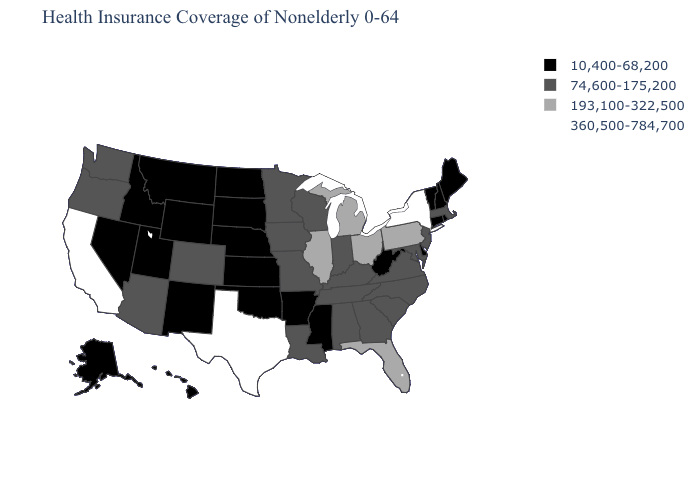Name the states that have a value in the range 193,100-322,500?
Answer briefly. Florida, Illinois, Michigan, Ohio, Pennsylvania. Name the states that have a value in the range 360,500-784,700?
Quick response, please. California, New York, Texas. What is the lowest value in the USA?
Short answer required. 10,400-68,200. Does Ohio have the same value as New Hampshire?
Answer briefly. No. How many symbols are there in the legend?
Answer briefly. 4. What is the lowest value in the USA?
Short answer required. 10,400-68,200. What is the highest value in the MidWest ?
Give a very brief answer. 193,100-322,500. Does Wyoming have the lowest value in the USA?
Be succinct. Yes. Name the states that have a value in the range 193,100-322,500?
Be succinct. Florida, Illinois, Michigan, Ohio, Pennsylvania. What is the highest value in states that border Louisiana?
Write a very short answer. 360,500-784,700. What is the value of Illinois?
Give a very brief answer. 193,100-322,500. What is the value of Minnesota?
Be succinct. 74,600-175,200. What is the value of Maryland?
Concise answer only. 74,600-175,200. Which states have the lowest value in the West?
Concise answer only. Alaska, Hawaii, Idaho, Montana, Nevada, New Mexico, Utah, Wyoming. Which states have the lowest value in the USA?
Answer briefly. Alaska, Arkansas, Connecticut, Delaware, Hawaii, Idaho, Kansas, Maine, Mississippi, Montana, Nebraska, Nevada, New Hampshire, New Mexico, North Dakota, Oklahoma, Rhode Island, South Dakota, Utah, Vermont, West Virginia, Wyoming. 